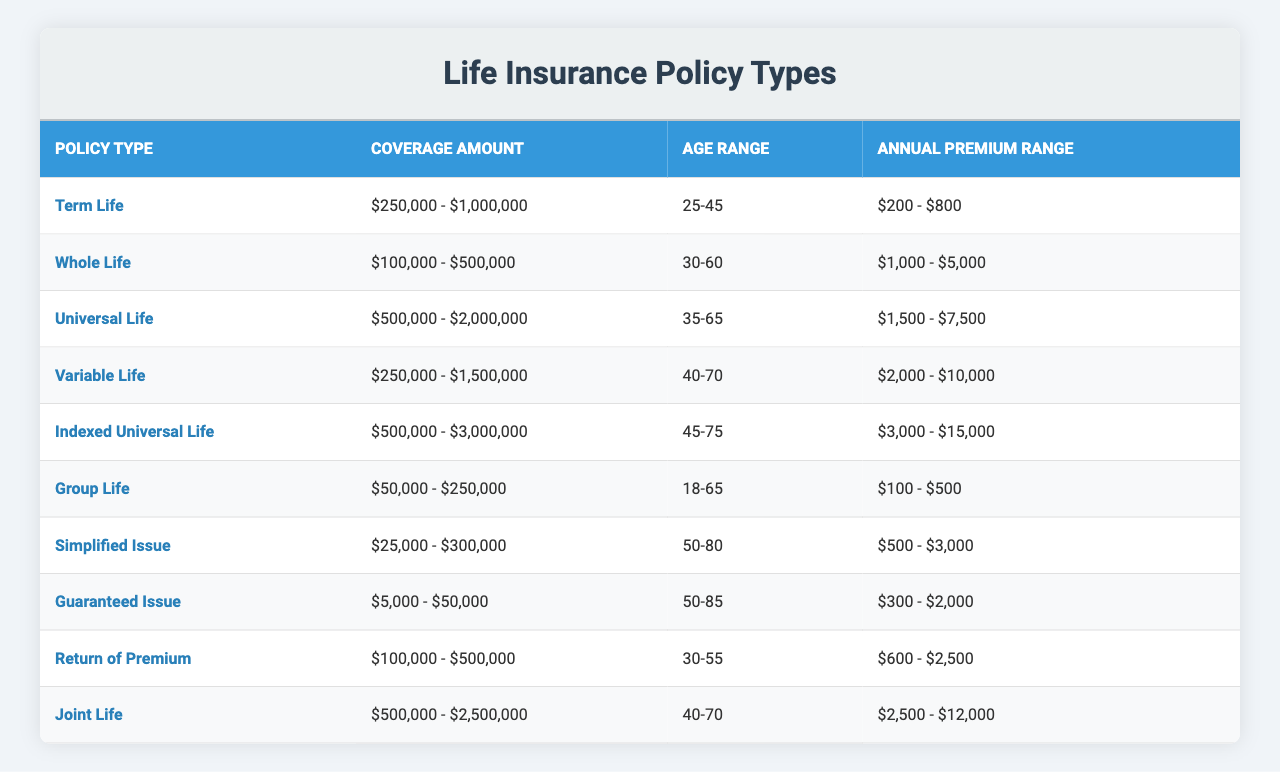What is the annual premium range for Whole Life insurance? The table indicates that the annual premium range for Whole Life insurance is between $1,000 and $5,000.
Answer: $1,000 - $5,000 Which policy type has the highest annual premium range? Comparing the annual premium ranges in the table, Indexed Universal Life has the highest range at $3,000 to $15,000.
Answer: Indexed Universal Life Is the coverage amount for Return of Premium higher or lower than that of Guaranteed Issue? The coverage amount for Return of Premium is $100,000 to $500,000, while Guaranteed Issue is $5,000 to $50,000, making Return of Premium higher.
Answer: Higher What is the age range for Variable Life insurance policies? According to the table, the age range for Variable Life insurance policies is 40 to 70 years old.
Answer: 40-70 How much does the coverage amount for Indexed Universal Life insurance exceed that for Universal Life insurance by? The coverage amount for Indexed Universal Life is $500,000 to $3,000,000, and for Universal Life, it is $500,000 to $2,000,000. The excess amount can be determined by comparing the upper limits: $3,000,000 - $2,000,000 = $1,000,000.
Answer: $1,000,000 Do all policies provide coverage for ages 65 and above? By checking the age ranges in the table, it is noted that Group Life only covers up to age 65 and does not include anyone above that age. Thus, not all policies cover ages 65 and above.
Answer: No What is the difference in annual premiums between the cheapest and the most expensive policy types? The cheapest policy is Group Life with an annual premium range of $100 to $500, and the most expensive is Indexed Universal Life with $3,000 to $15,000. The difference in the upper limits is $15,000 - $500 = $14,500.
Answer: $14,500 If a customer is 30 years old, which policy types are available to them based on the table? The available policy types for a 30-year-old, according to the age ranges in the table, are Term Life, Whole Life, Return of Premium, and Group Life.
Answer: Term Life, Whole Life, Return of Premium, Group Life What is the average coverage amount for all policy types listed? To find the average, we first identify that coverage amounts vary widely. However, a precise calculation involves averaging the midpoints from each range. For example, midpoints would be established, summed up, and divided by the number of policy types. Detailed calculations would yield a specific average, but initial estimates indicate it's approximately $1,000,000.
Answer: Approximately $1,000,000 Which policy type has the lowest minimum coverage amount? The table reveals that Guaranteed Issue has the lowest minimum coverage amount which starts at $5,000.
Answer: Guaranteed Issue 